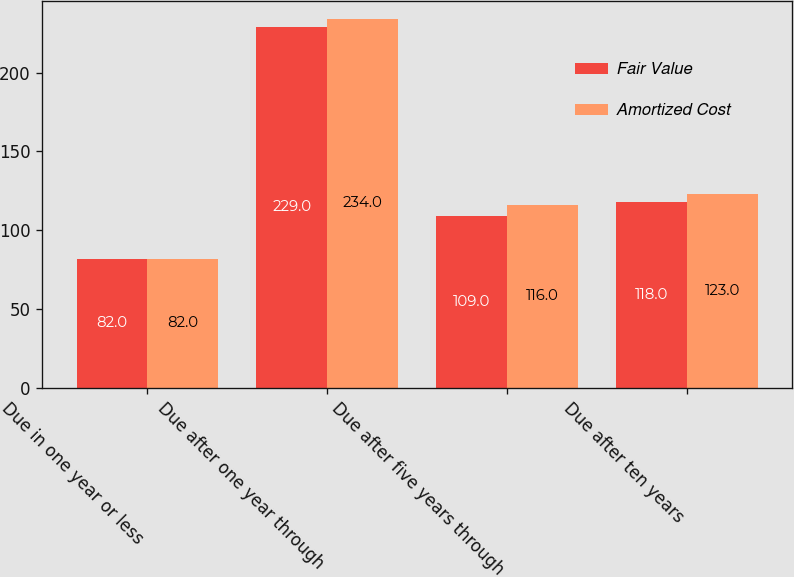Convert chart. <chart><loc_0><loc_0><loc_500><loc_500><stacked_bar_chart><ecel><fcel>Due in one year or less<fcel>Due after one year through<fcel>Due after five years through<fcel>Due after ten years<nl><fcel>Fair Value<fcel>82<fcel>229<fcel>109<fcel>118<nl><fcel>Amortized Cost<fcel>82<fcel>234<fcel>116<fcel>123<nl></chart> 